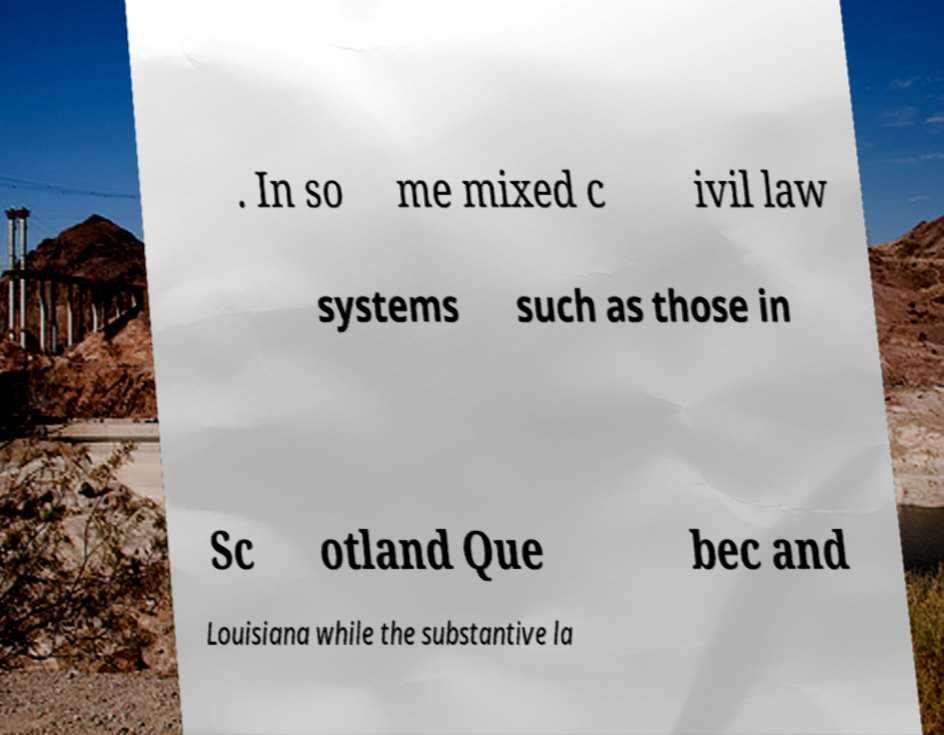Please read and relay the text visible in this image. What does it say? . In so me mixed c ivil law systems such as those in Sc otland Que bec and Louisiana while the substantive la 